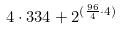Convert formula to latex. <formula><loc_0><loc_0><loc_500><loc_500>4 \cdot 3 3 4 + 2 ^ { ( \frac { 9 6 } { 4 } \cdot 4 ) }</formula> 